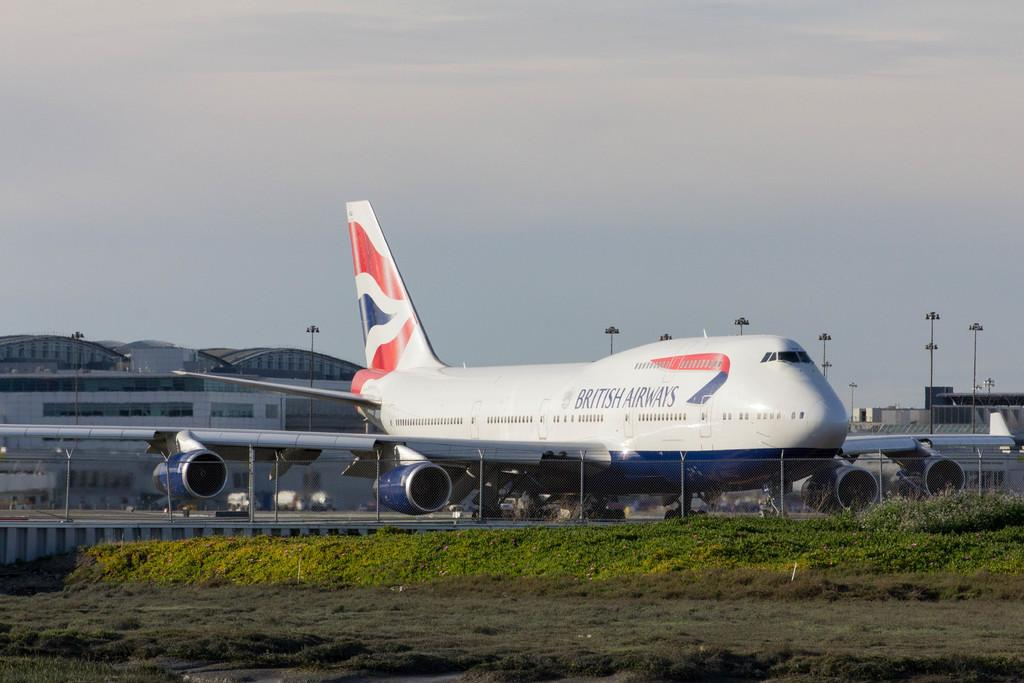Provide a one-sentence caption for the provided image. The airplane has British airlines on it and is on the ground. 